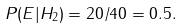<formula> <loc_0><loc_0><loc_500><loc_500>P ( E | H _ { 2 } ) = 2 0 / 4 0 = 0 . 5 .</formula> 